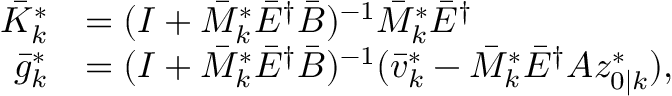Convert formula to latex. <formula><loc_0><loc_0><loc_500><loc_500>\begin{array} { r l } { \bar { K } _ { k } ^ { * } } & { = ( I + \bar { M } _ { k } ^ { * } \bar { E } ^ { \dagger } \bar { B } ) ^ { - 1 } \bar { M } _ { k } ^ { * } \bar { E } ^ { \dagger } } \\ { \bar { g } _ { k } ^ { * } } & { = ( I + \bar { M } _ { k } ^ { * } \bar { E } ^ { \dagger } \bar { B } ) ^ { - 1 } ( \bar { v } _ { k } ^ { * } - \bar { M } _ { k } ^ { * } \bar { E } ^ { \dagger } A z _ { 0 | k } ^ { * } ) , } \end{array}</formula> 